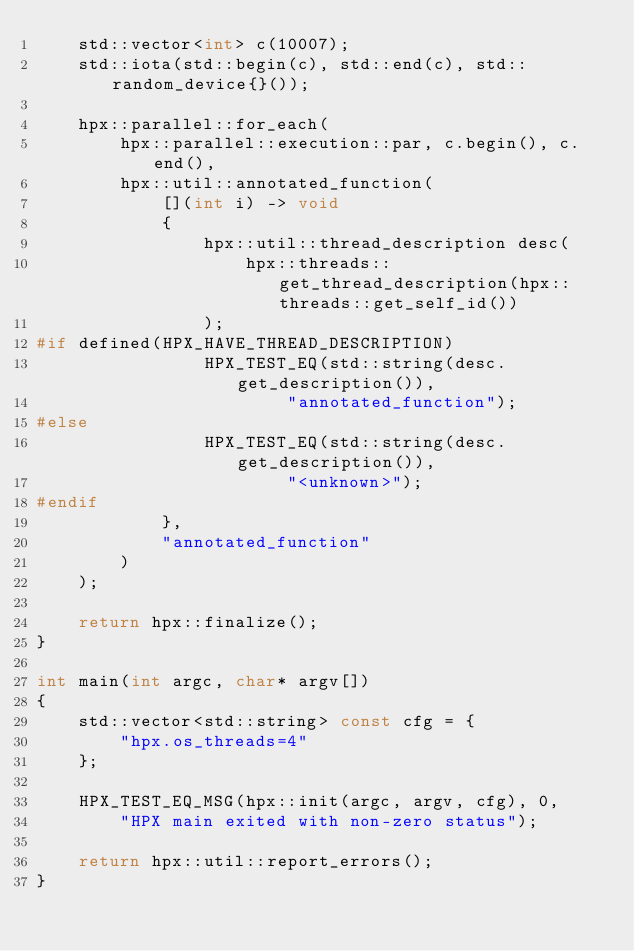<code> <loc_0><loc_0><loc_500><loc_500><_C++_>    std::vector<int> c(10007);
    std::iota(std::begin(c), std::end(c), std::random_device{}());

    hpx::parallel::for_each(
        hpx::parallel::execution::par, c.begin(), c.end(),
        hpx::util::annotated_function(
            [](int i) -> void
            {
                hpx::util::thread_description desc(
                    hpx::threads::get_thread_description(hpx::threads::get_self_id())
                );
#if defined(HPX_HAVE_THREAD_DESCRIPTION)
                HPX_TEST_EQ(std::string(desc.get_description()),
                        "annotated_function");
#else
                HPX_TEST_EQ(std::string(desc.get_description()),
                        "<unknown>");
#endif
            },
            "annotated_function"
        )
    );

    return hpx::finalize();
}

int main(int argc, char* argv[])
{
    std::vector<std::string> const cfg = {
        "hpx.os_threads=4"
    };

    HPX_TEST_EQ_MSG(hpx::init(argc, argv, cfg), 0,
        "HPX main exited with non-zero status");

    return hpx::util::report_errors();
}
</code> 